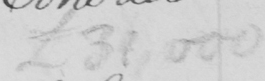Can you tell me what this handwritten text says? £31,000 